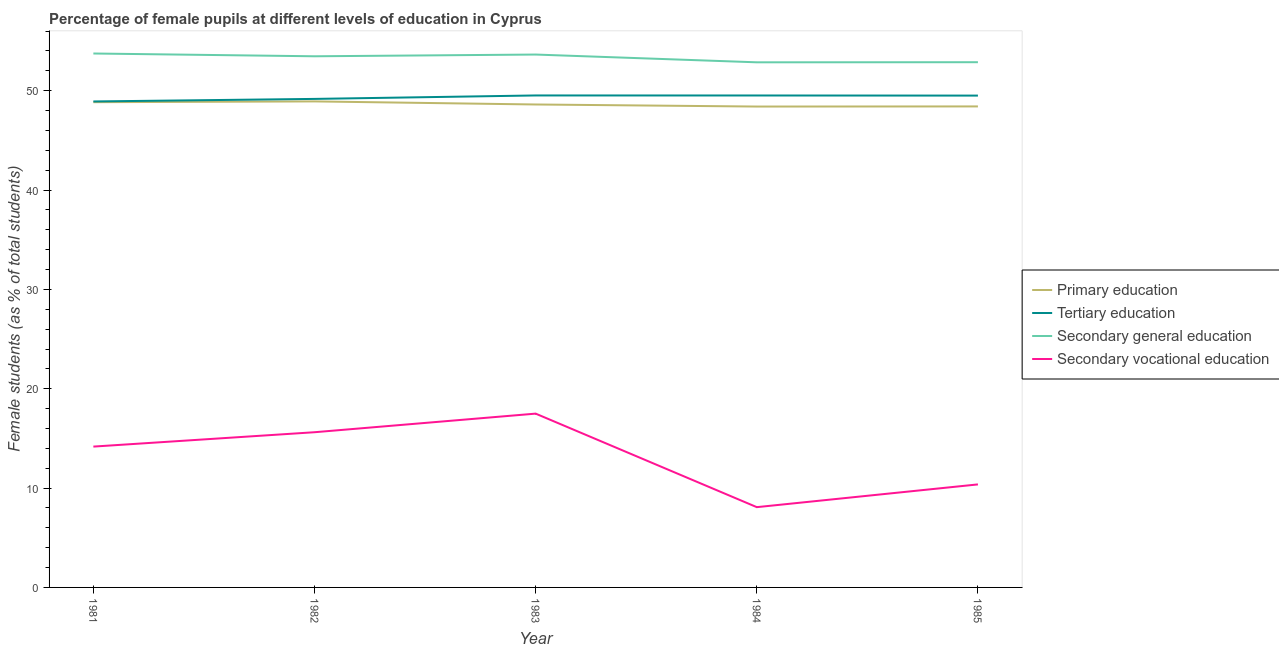What is the percentage of female students in secondary vocational education in 1981?
Make the answer very short. 14.18. Across all years, what is the maximum percentage of female students in secondary education?
Offer a terse response. 53.75. Across all years, what is the minimum percentage of female students in secondary vocational education?
Provide a succinct answer. 8.08. In which year was the percentage of female students in secondary education maximum?
Ensure brevity in your answer.  1981. What is the total percentage of female students in secondary education in the graph?
Your response must be concise. 266.59. What is the difference between the percentage of female students in tertiary education in 1983 and that in 1984?
Your response must be concise. 0. What is the difference between the percentage of female students in secondary education in 1984 and the percentage of female students in secondary vocational education in 1983?
Offer a terse response. 35.36. What is the average percentage of female students in primary education per year?
Provide a succinct answer. 48.64. In the year 1982, what is the difference between the percentage of female students in secondary education and percentage of female students in primary education?
Make the answer very short. 4.54. In how many years, is the percentage of female students in secondary vocational education greater than 6 %?
Make the answer very short. 5. What is the ratio of the percentage of female students in secondary education in 1982 to that in 1983?
Offer a terse response. 1. Is the difference between the percentage of female students in tertiary education in 1981 and 1985 greater than the difference between the percentage of female students in secondary education in 1981 and 1985?
Give a very brief answer. No. What is the difference between the highest and the second highest percentage of female students in primary education?
Provide a succinct answer. 0.08. What is the difference between the highest and the lowest percentage of female students in secondary education?
Your answer should be compact. 0.89. In how many years, is the percentage of female students in primary education greater than the average percentage of female students in primary education taken over all years?
Make the answer very short. 2. Is the sum of the percentage of female students in secondary vocational education in 1982 and 1984 greater than the maximum percentage of female students in primary education across all years?
Provide a succinct answer. No. Is it the case that in every year, the sum of the percentage of female students in tertiary education and percentage of female students in secondary vocational education is greater than the sum of percentage of female students in primary education and percentage of female students in secondary education?
Your response must be concise. No. Is it the case that in every year, the sum of the percentage of female students in primary education and percentage of female students in tertiary education is greater than the percentage of female students in secondary education?
Offer a terse response. Yes. Does the percentage of female students in secondary education monotonically increase over the years?
Provide a short and direct response. No. Is the percentage of female students in secondary education strictly greater than the percentage of female students in secondary vocational education over the years?
Make the answer very short. Yes. How many lines are there?
Make the answer very short. 4. How many years are there in the graph?
Your response must be concise. 5. What is the difference between two consecutive major ticks on the Y-axis?
Your answer should be compact. 10. Are the values on the major ticks of Y-axis written in scientific E-notation?
Provide a succinct answer. No. Does the graph contain any zero values?
Offer a terse response. No. How are the legend labels stacked?
Offer a very short reply. Vertical. What is the title of the graph?
Your response must be concise. Percentage of female pupils at different levels of education in Cyprus. What is the label or title of the Y-axis?
Offer a terse response. Female students (as % of total students). What is the Female students (as % of total students) in Primary education in 1981?
Make the answer very short. 48.85. What is the Female students (as % of total students) of Tertiary education in 1981?
Provide a short and direct response. 48.92. What is the Female students (as % of total students) in Secondary general education in 1981?
Provide a short and direct response. 53.75. What is the Female students (as % of total students) of Secondary vocational education in 1981?
Ensure brevity in your answer.  14.18. What is the Female students (as % of total students) in Primary education in 1982?
Your answer should be very brief. 48.93. What is the Female students (as % of total students) in Tertiary education in 1982?
Your answer should be very brief. 49.18. What is the Female students (as % of total students) of Secondary general education in 1982?
Provide a succinct answer. 53.47. What is the Female students (as % of total students) in Secondary vocational education in 1982?
Ensure brevity in your answer.  15.62. What is the Female students (as % of total students) in Primary education in 1983?
Offer a terse response. 48.61. What is the Female students (as % of total students) in Tertiary education in 1983?
Provide a succinct answer. 49.53. What is the Female students (as % of total students) in Secondary general education in 1983?
Your response must be concise. 53.64. What is the Female students (as % of total students) in Secondary vocational education in 1983?
Give a very brief answer. 17.5. What is the Female students (as % of total students) of Primary education in 1984?
Give a very brief answer. 48.41. What is the Female students (as % of total students) in Tertiary education in 1984?
Offer a very short reply. 49.52. What is the Female students (as % of total students) of Secondary general education in 1984?
Your answer should be compact. 52.86. What is the Female students (as % of total students) in Secondary vocational education in 1984?
Keep it short and to the point. 8.08. What is the Female students (as % of total students) in Primary education in 1985?
Offer a very short reply. 48.42. What is the Female students (as % of total students) in Tertiary education in 1985?
Keep it short and to the point. 49.51. What is the Female students (as % of total students) in Secondary general education in 1985?
Give a very brief answer. 52.87. What is the Female students (as % of total students) in Secondary vocational education in 1985?
Offer a very short reply. 10.37. Across all years, what is the maximum Female students (as % of total students) in Primary education?
Keep it short and to the point. 48.93. Across all years, what is the maximum Female students (as % of total students) in Tertiary education?
Ensure brevity in your answer.  49.53. Across all years, what is the maximum Female students (as % of total students) in Secondary general education?
Keep it short and to the point. 53.75. Across all years, what is the maximum Female students (as % of total students) of Secondary vocational education?
Give a very brief answer. 17.5. Across all years, what is the minimum Female students (as % of total students) in Primary education?
Ensure brevity in your answer.  48.41. Across all years, what is the minimum Female students (as % of total students) of Tertiary education?
Keep it short and to the point. 48.92. Across all years, what is the minimum Female students (as % of total students) of Secondary general education?
Make the answer very short. 52.86. Across all years, what is the minimum Female students (as % of total students) of Secondary vocational education?
Provide a short and direct response. 8.08. What is the total Female students (as % of total students) in Primary education in the graph?
Ensure brevity in your answer.  243.22. What is the total Female students (as % of total students) of Tertiary education in the graph?
Give a very brief answer. 246.65. What is the total Female students (as % of total students) of Secondary general education in the graph?
Provide a succinct answer. 266.59. What is the total Female students (as % of total students) in Secondary vocational education in the graph?
Offer a very short reply. 65.75. What is the difference between the Female students (as % of total students) of Primary education in 1981 and that in 1982?
Provide a succinct answer. -0.08. What is the difference between the Female students (as % of total students) of Tertiary education in 1981 and that in 1982?
Your response must be concise. -0.26. What is the difference between the Female students (as % of total students) in Secondary general education in 1981 and that in 1982?
Your response must be concise. 0.28. What is the difference between the Female students (as % of total students) of Secondary vocational education in 1981 and that in 1982?
Make the answer very short. -1.45. What is the difference between the Female students (as % of total students) in Primary education in 1981 and that in 1983?
Offer a terse response. 0.23. What is the difference between the Female students (as % of total students) in Tertiary education in 1981 and that in 1983?
Ensure brevity in your answer.  -0.6. What is the difference between the Female students (as % of total students) in Secondary general education in 1981 and that in 1983?
Ensure brevity in your answer.  0.11. What is the difference between the Female students (as % of total students) in Secondary vocational education in 1981 and that in 1983?
Keep it short and to the point. -3.32. What is the difference between the Female students (as % of total students) of Primary education in 1981 and that in 1984?
Make the answer very short. 0.44. What is the difference between the Female students (as % of total students) of Tertiary education in 1981 and that in 1984?
Your answer should be very brief. -0.6. What is the difference between the Female students (as % of total students) of Secondary general education in 1981 and that in 1984?
Provide a succinct answer. 0.89. What is the difference between the Female students (as % of total students) in Secondary vocational education in 1981 and that in 1984?
Make the answer very short. 6.1. What is the difference between the Female students (as % of total students) in Primary education in 1981 and that in 1985?
Provide a succinct answer. 0.43. What is the difference between the Female students (as % of total students) of Tertiary education in 1981 and that in 1985?
Offer a terse response. -0.59. What is the difference between the Female students (as % of total students) of Secondary general education in 1981 and that in 1985?
Your answer should be very brief. 0.87. What is the difference between the Female students (as % of total students) in Secondary vocational education in 1981 and that in 1985?
Provide a succinct answer. 3.81. What is the difference between the Female students (as % of total students) in Primary education in 1982 and that in 1983?
Offer a very short reply. 0.31. What is the difference between the Female students (as % of total students) in Tertiary education in 1982 and that in 1983?
Provide a short and direct response. -0.35. What is the difference between the Female students (as % of total students) of Secondary general education in 1982 and that in 1983?
Offer a very short reply. -0.17. What is the difference between the Female students (as % of total students) of Secondary vocational education in 1982 and that in 1983?
Offer a terse response. -1.87. What is the difference between the Female students (as % of total students) in Primary education in 1982 and that in 1984?
Offer a terse response. 0.52. What is the difference between the Female students (as % of total students) in Tertiary education in 1982 and that in 1984?
Your response must be concise. -0.34. What is the difference between the Female students (as % of total students) of Secondary general education in 1982 and that in 1984?
Offer a very short reply. 0.61. What is the difference between the Female students (as % of total students) of Secondary vocational education in 1982 and that in 1984?
Your response must be concise. 7.54. What is the difference between the Female students (as % of total students) of Primary education in 1982 and that in 1985?
Provide a short and direct response. 0.5. What is the difference between the Female students (as % of total students) in Tertiary education in 1982 and that in 1985?
Keep it short and to the point. -0.33. What is the difference between the Female students (as % of total students) of Secondary general education in 1982 and that in 1985?
Your answer should be very brief. 0.6. What is the difference between the Female students (as % of total students) of Secondary vocational education in 1982 and that in 1985?
Offer a very short reply. 5.25. What is the difference between the Female students (as % of total students) in Primary education in 1983 and that in 1984?
Provide a short and direct response. 0.21. What is the difference between the Female students (as % of total students) in Tertiary education in 1983 and that in 1984?
Make the answer very short. 0. What is the difference between the Female students (as % of total students) in Secondary general education in 1983 and that in 1984?
Your response must be concise. 0.78. What is the difference between the Female students (as % of total students) in Secondary vocational education in 1983 and that in 1984?
Give a very brief answer. 9.41. What is the difference between the Female students (as % of total students) in Primary education in 1983 and that in 1985?
Keep it short and to the point. 0.19. What is the difference between the Female students (as % of total students) of Tertiary education in 1983 and that in 1985?
Ensure brevity in your answer.  0.02. What is the difference between the Female students (as % of total students) in Secondary general education in 1983 and that in 1985?
Keep it short and to the point. 0.77. What is the difference between the Female students (as % of total students) of Secondary vocational education in 1983 and that in 1985?
Offer a very short reply. 7.13. What is the difference between the Female students (as % of total students) in Primary education in 1984 and that in 1985?
Give a very brief answer. -0.01. What is the difference between the Female students (as % of total students) in Tertiary education in 1984 and that in 1985?
Your answer should be very brief. 0.01. What is the difference between the Female students (as % of total students) of Secondary general education in 1984 and that in 1985?
Provide a short and direct response. -0.01. What is the difference between the Female students (as % of total students) in Secondary vocational education in 1984 and that in 1985?
Your answer should be very brief. -2.29. What is the difference between the Female students (as % of total students) in Primary education in 1981 and the Female students (as % of total students) in Tertiary education in 1982?
Give a very brief answer. -0.33. What is the difference between the Female students (as % of total students) of Primary education in 1981 and the Female students (as % of total students) of Secondary general education in 1982?
Make the answer very short. -4.62. What is the difference between the Female students (as % of total students) of Primary education in 1981 and the Female students (as % of total students) of Secondary vocational education in 1982?
Give a very brief answer. 33.22. What is the difference between the Female students (as % of total students) in Tertiary education in 1981 and the Female students (as % of total students) in Secondary general education in 1982?
Give a very brief answer. -4.55. What is the difference between the Female students (as % of total students) in Tertiary education in 1981 and the Female students (as % of total students) in Secondary vocational education in 1982?
Keep it short and to the point. 33.3. What is the difference between the Female students (as % of total students) in Secondary general education in 1981 and the Female students (as % of total students) in Secondary vocational education in 1982?
Provide a succinct answer. 38.12. What is the difference between the Female students (as % of total students) of Primary education in 1981 and the Female students (as % of total students) of Tertiary education in 1983?
Your answer should be very brief. -0.68. What is the difference between the Female students (as % of total students) of Primary education in 1981 and the Female students (as % of total students) of Secondary general education in 1983?
Make the answer very short. -4.79. What is the difference between the Female students (as % of total students) of Primary education in 1981 and the Female students (as % of total students) of Secondary vocational education in 1983?
Offer a terse response. 31.35. What is the difference between the Female students (as % of total students) in Tertiary education in 1981 and the Female students (as % of total students) in Secondary general education in 1983?
Your response must be concise. -4.72. What is the difference between the Female students (as % of total students) in Tertiary education in 1981 and the Female students (as % of total students) in Secondary vocational education in 1983?
Keep it short and to the point. 31.43. What is the difference between the Female students (as % of total students) in Secondary general education in 1981 and the Female students (as % of total students) in Secondary vocational education in 1983?
Offer a terse response. 36.25. What is the difference between the Female students (as % of total students) in Primary education in 1981 and the Female students (as % of total students) in Tertiary education in 1984?
Offer a terse response. -0.67. What is the difference between the Female students (as % of total students) of Primary education in 1981 and the Female students (as % of total students) of Secondary general education in 1984?
Provide a succinct answer. -4.01. What is the difference between the Female students (as % of total students) in Primary education in 1981 and the Female students (as % of total students) in Secondary vocational education in 1984?
Offer a terse response. 40.77. What is the difference between the Female students (as % of total students) of Tertiary education in 1981 and the Female students (as % of total students) of Secondary general education in 1984?
Your response must be concise. -3.94. What is the difference between the Female students (as % of total students) in Tertiary education in 1981 and the Female students (as % of total students) in Secondary vocational education in 1984?
Provide a succinct answer. 40.84. What is the difference between the Female students (as % of total students) of Secondary general education in 1981 and the Female students (as % of total students) of Secondary vocational education in 1984?
Your answer should be compact. 45.67. What is the difference between the Female students (as % of total students) in Primary education in 1981 and the Female students (as % of total students) in Tertiary education in 1985?
Give a very brief answer. -0.66. What is the difference between the Female students (as % of total students) in Primary education in 1981 and the Female students (as % of total students) in Secondary general education in 1985?
Ensure brevity in your answer.  -4.03. What is the difference between the Female students (as % of total students) in Primary education in 1981 and the Female students (as % of total students) in Secondary vocational education in 1985?
Offer a terse response. 38.48. What is the difference between the Female students (as % of total students) in Tertiary education in 1981 and the Female students (as % of total students) in Secondary general education in 1985?
Offer a terse response. -3.95. What is the difference between the Female students (as % of total students) in Tertiary education in 1981 and the Female students (as % of total students) in Secondary vocational education in 1985?
Make the answer very short. 38.55. What is the difference between the Female students (as % of total students) of Secondary general education in 1981 and the Female students (as % of total students) of Secondary vocational education in 1985?
Provide a succinct answer. 43.38. What is the difference between the Female students (as % of total students) in Primary education in 1982 and the Female students (as % of total students) in Secondary general education in 1983?
Ensure brevity in your answer.  -4.72. What is the difference between the Female students (as % of total students) in Primary education in 1982 and the Female students (as % of total students) in Secondary vocational education in 1983?
Provide a succinct answer. 31.43. What is the difference between the Female students (as % of total students) in Tertiary education in 1982 and the Female students (as % of total students) in Secondary general education in 1983?
Provide a short and direct response. -4.47. What is the difference between the Female students (as % of total students) of Tertiary education in 1982 and the Female students (as % of total students) of Secondary vocational education in 1983?
Provide a short and direct response. 31.68. What is the difference between the Female students (as % of total students) in Secondary general education in 1982 and the Female students (as % of total students) in Secondary vocational education in 1983?
Your response must be concise. 35.97. What is the difference between the Female students (as % of total students) of Primary education in 1982 and the Female students (as % of total students) of Tertiary education in 1984?
Keep it short and to the point. -0.6. What is the difference between the Female students (as % of total students) of Primary education in 1982 and the Female students (as % of total students) of Secondary general education in 1984?
Your response must be concise. -3.94. What is the difference between the Female students (as % of total students) in Primary education in 1982 and the Female students (as % of total students) in Secondary vocational education in 1984?
Provide a succinct answer. 40.84. What is the difference between the Female students (as % of total students) in Tertiary education in 1982 and the Female students (as % of total students) in Secondary general education in 1984?
Your response must be concise. -3.68. What is the difference between the Female students (as % of total students) of Tertiary education in 1982 and the Female students (as % of total students) of Secondary vocational education in 1984?
Offer a terse response. 41.09. What is the difference between the Female students (as % of total students) of Secondary general education in 1982 and the Female students (as % of total students) of Secondary vocational education in 1984?
Keep it short and to the point. 45.39. What is the difference between the Female students (as % of total students) of Primary education in 1982 and the Female students (as % of total students) of Tertiary education in 1985?
Make the answer very short. -0.58. What is the difference between the Female students (as % of total students) in Primary education in 1982 and the Female students (as % of total students) in Secondary general education in 1985?
Make the answer very short. -3.95. What is the difference between the Female students (as % of total students) in Primary education in 1982 and the Female students (as % of total students) in Secondary vocational education in 1985?
Your answer should be compact. 38.55. What is the difference between the Female students (as % of total students) in Tertiary education in 1982 and the Female students (as % of total students) in Secondary general education in 1985?
Provide a succinct answer. -3.7. What is the difference between the Female students (as % of total students) in Tertiary education in 1982 and the Female students (as % of total students) in Secondary vocational education in 1985?
Your response must be concise. 38.81. What is the difference between the Female students (as % of total students) of Secondary general education in 1982 and the Female students (as % of total students) of Secondary vocational education in 1985?
Ensure brevity in your answer.  43.1. What is the difference between the Female students (as % of total students) in Primary education in 1983 and the Female students (as % of total students) in Tertiary education in 1984?
Provide a succinct answer. -0.91. What is the difference between the Female students (as % of total students) in Primary education in 1983 and the Female students (as % of total students) in Secondary general education in 1984?
Ensure brevity in your answer.  -4.25. What is the difference between the Female students (as % of total students) of Primary education in 1983 and the Female students (as % of total students) of Secondary vocational education in 1984?
Your answer should be very brief. 40.53. What is the difference between the Female students (as % of total students) of Tertiary education in 1983 and the Female students (as % of total students) of Secondary general education in 1984?
Offer a terse response. -3.34. What is the difference between the Female students (as % of total students) of Tertiary education in 1983 and the Female students (as % of total students) of Secondary vocational education in 1984?
Provide a short and direct response. 41.44. What is the difference between the Female students (as % of total students) in Secondary general education in 1983 and the Female students (as % of total students) in Secondary vocational education in 1984?
Keep it short and to the point. 45.56. What is the difference between the Female students (as % of total students) of Primary education in 1983 and the Female students (as % of total students) of Tertiary education in 1985?
Keep it short and to the point. -0.9. What is the difference between the Female students (as % of total students) of Primary education in 1983 and the Female students (as % of total students) of Secondary general education in 1985?
Your answer should be compact. -4.26. What is the difference between the Female students (as % of total students) in Primary education in 1983 and the Female students (as % of total students) in Secondary vocational education in 1985?
Your response must be concise. 38.24. What is the difference between the Female students (as % of total students) in Tertiary education in 1983 and the Female students (as % of total students) in Secondary general education in 1985?
Provide a short and direct response. -3.35. What is the difference between the Female students (as % of total students) in Tertiary education in 1983 and the Female students (as % of total students) in Secondary vocational education in 1985?
Your answer should be very brief. 39.15. What is the difference between the Female students (as % of total students) in Secondary general education in 1983 and the Female students (as % of total students) in Secondary vocational education in 1985?
Your answer should be very brief. 43.27. What is the difference between the Female students (as % of total students) of Primary education in 1984 and the Female students (as % of total students) of Tertiary education in 1985?
Make the answer very short. -1.1. What is the difference between the Female students (as % of total students) of Primary education in 1984 and the Female students (as % of total students) of Secondary general education in 1985?
Your answer should be very brief. -4.46. What is the difference between the Female students (as % of total students) in Primary education in 1984 and the Female students (as % of total students) in Secondary vocational education in 1985?
Your answer should be very brief. 38.04. What is the difference between the Female students (as % of total students) in Tertiary education in 1984 and the Female students (as % of total students) in Secondary general education in 1985?
Provide a short and direct response. -3.35. What is the difference between the Female students (as % of total students) of Tertiary education in 1984 and the Female students (as % of total students) of Secondary vocational education in 1985?
Offer a very short reply. 39.15. What is the difference between the Female students (as % of total students) in Secondary general education in 1984 and the Female students (as % of total students) in Secondary vocational education in 1985?
Offer a terse response. 42.49. What is the average Female students (as % of total students) in Primary education per year?
Offer a very short reply. 48.64. What is the average Female students (as % of total students) of Tertiary education per year?
Provide a succinct answer. 49.33. What is the average Female students (as % of total students) of Secondary general education per year?
Offer a very short reply. 53.32. What is the average Female students (as % of total students) in Secondary vocational education per year?
Provide a short and direct response. 13.15. In the year 1981, what is the difference between the Female students (as % of total students) of Primary education and Female students (as % of total students) of Tertiary education?
Keep it short and to the point. -0.07. In the year 1981, what is the difference between the Female students (as % of total students) in Primary education and Female students (as % of total students) in Secondary general education?
Provide a short and direct response. -4.9. In the year 1981, what is the difference between the Female students (as % of total students) of Primary education and Female students (as % of total students) of Secondary vocational education?
Offer a terse response. 34.67. In the year 1981, what is the difference between the Female students (as % of total students) in Tertiary education and Female students (as % of total students) in Secondary general education?
Your response must be concise. -4.83. In the year 1981, what is the difference between the Female students (as % of total students) in Tertiary education and Female students (as % of total students) in Secondary vocational education?
Ensure brevity in your answer.  34.74. In the year 1981, what is the difference between the Female students (as % of total students) of Secondary general education and Female students (as % of total students) of Secondary vocational education?
Offer a terse response. 39.57. In the year 1982, what is the difference between the Female students (as % of total students) of Primary education and Female students (as % of total students) of Tertiary education?
Keep it short and to the point. -0.25. In the year 1982, what is the difference between the Female students (as % of total students) in Primary education and Female students (as % of total students) in Secondary general education?
Your answer should be very brief. -4.54. In the year 1982, what is the difference between the Female students (as % of total students) in Primary education and Female students (as % of total students) in Secondary vocational education?
Give a very brief answer. 33.3. In the year 1982, what is the difference between the Female students (as % of total students) of Tertiary education and Female students (as % of total students) of Secondary general education?
Your response must be concise. -4.29. In the year 1982, what is the difference between the Female students (as % of total students) of Tertiary education and Female students (as % of total students) of Secondary vocational education?
Offer a terse response. 33.55. In the year 1982, what is the difference between the Female students (as % of total students) in Secondary general education and Female students (as % of total students) in Secondary vocational education?
Offer a very short reply. 37.84. In the year 1983, what is the difference between the Female students (as % of total students) in Primary education and Female students (as % of total students) in Tertiary education?
Ensure brevity in your answer.  -0.91. In the year 1983, what is the difference between the Female students (as % of total students) in Primary education and Female students (as % of total students) in Secondary general education?
Your answer should be compact. -5.03. In the year 1983, what is the difference between the Female students (as % of total students) of Primary education and Female students (as % of total students) of Secondary vocational education?
Your answer should be very brief. 31.12. In the year 1983, what is the difference between the Female students (as % of total students) in Tertiary education and Female students (as % of total students) in Secondary general education?
Your response must be concise. -4.12. In the year 1983, what is the difference between the Female students (as % of total students) of Tertiary education and Female students (as % of total students) of Secondary vocational education?
Your response must be concise. 32.03. In the year 1983, what is the difference between the Female students (as % of total students) of Secondary general education and Female students (as % of total students) of Secondary vocational education?
Your response must be concise. 36.15. In the year 1984, what is the difference between the Female students (as % of total students) in Primary education and Female students (as % of total students) in Tertiary education?
Provide a short and direct response. -1.11. In the year 1984, what is the difference between the Female students (as % of total students) in Primary education and Female students (as % of total students) in Secondary general education?
Keep it short and to the point. -4.45. In the year 1984, what is the difference between the Female students (as % of total students) of Primary education and Female students (as % of total students) of Secondary vocational education?
Give a very brief answer. 40.33. In the year 1984, what is the difference between the Female students (as % of total students) of Tertiary education and Female students (as % of total students) of Secondary general education?
Provide a short and direct response. -3.34. In the year 1984, what is the difference between the Female students (as % of total students) of Tertiary education and Female students (as % of total students) of Secondary vocational education?
Provide a succinct answer. 41.44. In the year 1984, what is the difference between the Female students (as % of total students) in Secondary general education and Female students (as % of total students) in Secondary vocational education?
Your response must be concise. 44.78. In the year 1985, what is the difference between the Female students (as % of total students) of Primary education and Female students (as % of total students) of Tertiary education?
Your response must be concise. -1.09. In the year 1985, what is the difference between the Female students (as % of total students) in Primary education and Female students (as % of total students) in Secondary general education?
Your response must be concise. -4.45. In the year 1985, what is the difference between the Female students (as % of total students) of Primary education and Female students (as % of total students) of Secondary vocational education?
Your response must be concise. 38.05. In the year 1985, what is the difference between the Female students (as % of total students) in Tertiary education and Female students (as % of total students) in Secondary general education?
Offer a terse response. -3.36. In the year 1985, what is the difference between the Female students (as % of total students) of Tertiary education and Female students (as % of total students) of Secondary vocational education?
Keep it short and to the point. 39.14. In the year 1985, what is the difference between the Female students (as % of total students) in Secondary general education and Female students (as % of total students) in Secondary vocational education?
Your answer should be very brief. 42.5. What is the ratio of the Female students (as % of total students) of Primary education in 1981 to that in 1982?
Your response must be concise. 1. What is the ratio of the Female students (as % of total students) in Tertiary education in 1981 to that in 1982?
Ensure brevity in your answer.  0.99. What is the ratio of the Female students (as % of total students) in Secondary general education in 1981 to that in 1982?
Provide a succinct answer. 1.01. What is the ratio of the Female students (as % of total students) of Secondary vocational education in 1981 to that in 1982?
Your answer should be very brief. 0.91. What is the ratio of the Female students (as % of total students) in Primary education in 1981 to that in 1983?
Keep it short and to the point. 1. What is the ratio of the Female students (as % of total students) in Tertiary education in 1981 to that in 1983?
Your answer should be very brief. 0.99. What is the ratio of the Female students (as % of total students) in Secondary general education in 1981 to that in 1983?
Your answer should be very brief. 1. What is the ratio of the Female students (as % of total students) in Secondary vocational education in 1981 to that in 1983?
Make the answer very short. 0.81. What is the ratio of the Female students (as % of total students) of Primary education in 1981 to that in 1984?
Give a very brief answer. 1.01. What is the ratio of the Female students (as % of total students) in Tertiary education in 1981 to that in 1984?
Your answer should be very brief. 0.99. What is the ratio of the Female students (as % of total students) of Secondary general education in 1981 to that in 1984?
Offer a very short reply. 1.02. What is the ratio of the Female students (as % of total students) of Secondary vocational education in 1981 to that in 1984?
Provide a succinct answer. 1.75. What is the ratio of the Female students (as % of total students) in Primary education in 1981 to that in 1985?
Your answer should be very brief. 1.01. What is the ratio of the Female students (as % of total students) in Secondary general education in 1981 to that in 1985?
Your answer should be very brief. 1.02. What is the ratio of the Female students (as % of total students) of Secondary vocational education in 1981 to that in 1985?
Provide a succinct answer. 1.37. What is the ratio of the Female students (as % of total students) in Primary education in 1982 to that in 1983?
Your answer should be compact. 1.01. What is the ratio of the Female students (as % of total students) of Secondary general education in 1982 to that in 1983?
Provide a short and direct response. 1. What is the ratio of the Female students (as % of total students) in Secondary vocational education in 1982 to that in 1983?
Provide a succinct answer. 0.89. What is the ratio of the Female students (as % of total students) of Primary education in 1982 to that in 1984?
Provide a succinct answer. 1.01. What is the ratio of the Female students (as % of total students) in Tertiary education in 1982 to that in 1984?
Keep it short and to the point. 0.99. What is the ratio of the Female students (as % of total students) of Secondary general education in 1982 to that in 1984?
Ensure brevity in your answer.  1.01. What is the ratio of the Female students (as % of total students) in Secondary vocational education in 1982 to that in 1984?
Your response must be concise. 1.93. What is the ratio of the Female students (as % of total students) of Primary education in 1982 to that in 1985?
Offer a very short reply. 1.01. What is the ratio of the Female students (as % of total students) of Tertiary education in 1982 to that in 1985?
Your answer should be compact. 0.99. What is the ratio of the Female students (as % of total students) of Secondary general education in 1982 to that in 1985?
Provide a succinct answer. 1.01. What is the ratio of the Female students (as % of total students) of Secondary vocational education in 1982 to that in 1985?
Your answer should be compact. 1.51. What is the ratio of the Female students (as % of total students) of Primary education in 1983 to that in 1984?
Your answer should be very brief. 1. What is the ratio of the Female students (as % of total students) of Secondary general education in 1983 to that in 1984?
Give a very brief answer. 1.01. What is the ratio of the Female students (as % of total students) of Secondary vocational education in 1983 to that in 1984?
Your answer should be very brief. 2.16. What is the ratio of the Female students (as % of total students) of Primary education in 1983 to that in 1985?
Provide a short and direct response. 1. What is the ratio of the Female students (as % of total students) in Secondary general education in 1983 to that in 1985?
Provide a short and direct response. 1.01. What is the ratio of the Female students (as % of total students) of Secondary vocational education in 1983 to that in 1985?
Offer a very short reply. 1.69. What is the ratio of the Female students (as % of total students) of Secondary vocational education in 1984 to that in 1985?
Provide a succinct answer. 0.78. What is the difference between the highest and the second highest Female students (as % of total students) in Primary education?
Offer a very short reply. 0.08. What is the difference between the highest and the second highest Female students (as % of total students) in Tertiary education?
Your answer should be compact. 0. What is the difference between the highest and the second highest Female students (as % of total students) of Secondary general education?
Make the answer very short. 0.11. What is the difference between the highest and the second highest Female students (as % of total students) of Secondary vocational education?
Keep it short and to the point. 1.87. What is the difference between the highest and the lowest Female students (as % of total students) of Primary education?
Provide a short and direct response. 0.52. What is the difference between the highest and the lowest Female students (as % of total students) in Tertiary education?
Keep it short and to the point. 0.6. What is the difference between the highest and the lowest Female students (as % of total students) of Secondary general education?
Offer a terse response. 0.89. What is the difference between the highest and the lowest Female students (as % of total students) in Secondary vocational education?
Offer a terse response. 9.41. 